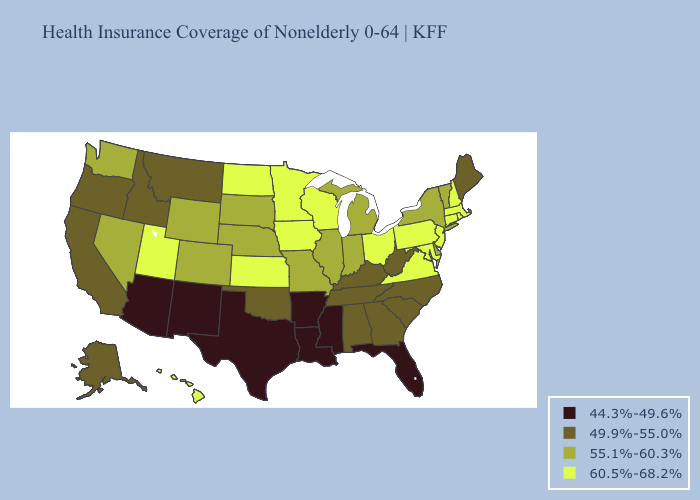Name the states that have a value in the range 60.5%-68.2%?
Answer briefly. Connecticut, Hawaii, Iowa, Kansas, Maryland, Massachusetts, Minnesota, New Hampshire, New Jersey, North Dakota, Ohio, Pennsylvania, Rhode Island, Utah, Virginia, Wisconsin. Among the states that border Georgia , does Tennessee have the lowest value?
Concise answer only. No. What is the lowest value in the West?
Quick response, please. 44.3%-49.6%. What is the highest value in the USA?
Concise answer only. 60.5%-68.2%. What is the value of Minnesota?
Quick response, please. 60.5%-68.2%. Among the states that border Washington , which have the lowest value?
Be succinct. Idaho, Oregon. Name the states that have a value in the range 55.1%-60.3%?
Keep it brief. Colorado, Delaware, Illinois, Indiana, Michigan, Missouri, Nebraska, Nevada, New York, South Dakota, Vermont, Washington, Wyoming. What is the value of Missouri?
Quick response, please. 55.1%-60.3%. Is the legend a continuous bar?
Keep it brief. No. What is the value of Connecticut?
Keep it brief. 60.5%-68.2%. What is the highest value in the Northeast ?
Write a very short answer. 60.5%-68.2%. What is the lowest value in the Northeast?
Short answer required. 49.9%-55.0%. What is the highest value in states that border New Jersey?
Keep it brief. 60.5%-68.2%. What is the lowest value in states that border North Carolina?
Write a very short answer. 49.9%-55.0%. Which states have the lowest value in the USA?
Keep it brief. Arizona, Arkansas, Florida, Louisiana, Mississippi, New Mexico, Texas. 